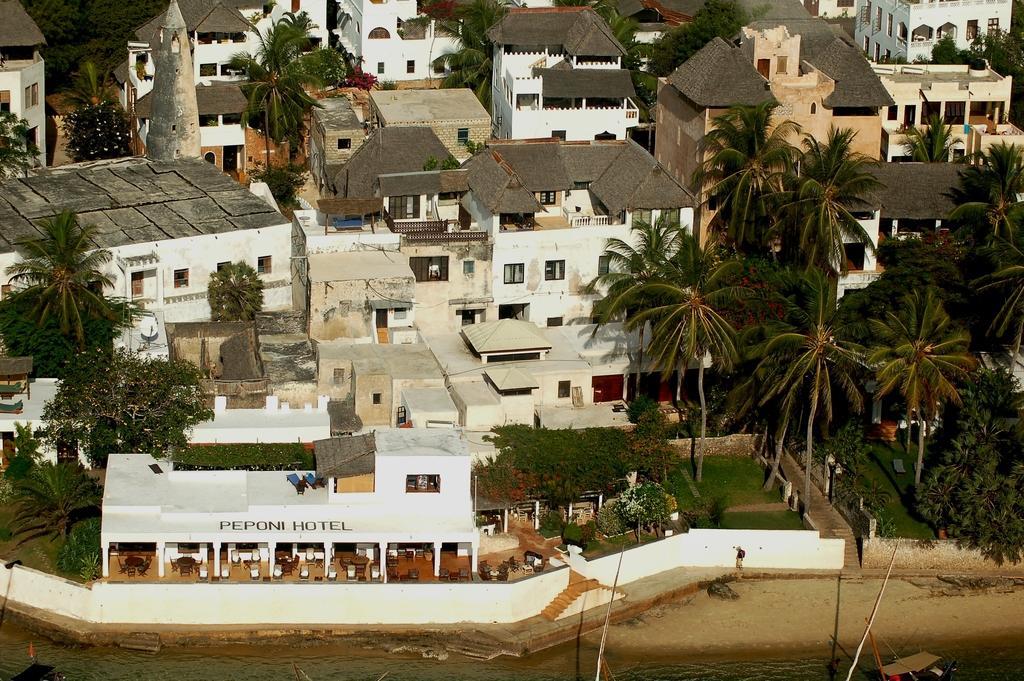Please provide a concise description of this image. In this image I can see a hotel. I can see many trees and green grass. In the background I can see many houses. 